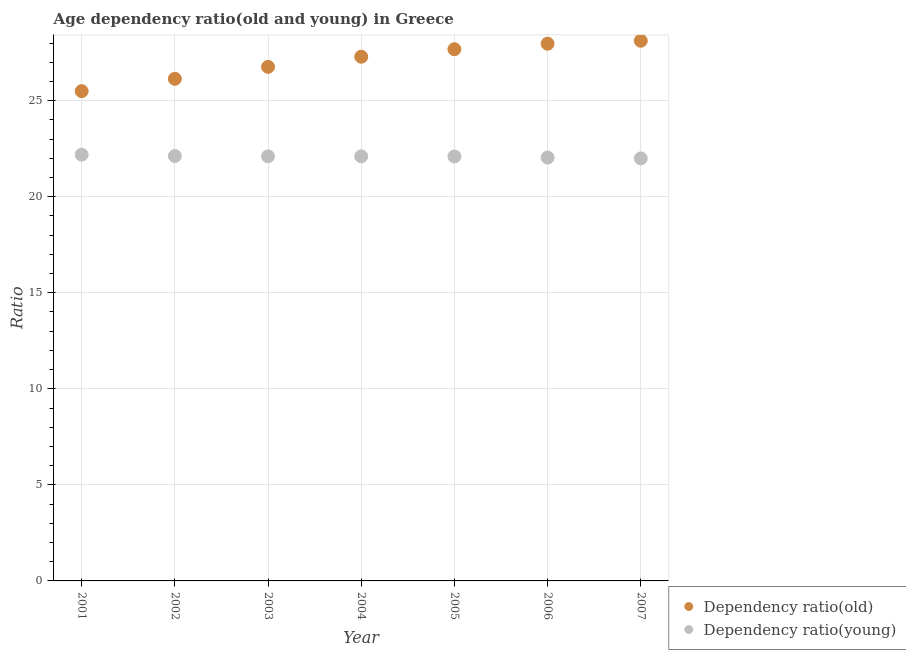How many different coloured dotlines are there?
Make the answer very short. 2. Is the number of dotlines equal to the number of legend labels?
Your answer should be very brief. Yes. What is the age dependency ratio(old) in 2004?
Give a very brief answer. 27.29. Across all years, what is the maximum age dependency ratio(old)?
Your response must be concise. 28.12. Across all years, what is the minimum age dependency ratio(young)?
Give a very brief answer. 21.99. In which year was the age dependency ratio(young) maximum?
Ensure brevity in your answer.  2001. What is the total age dependency ratio(old) in the graph?
Provide a succinct answer. 189.44. What is the difference between the age dependency ratio(old) in 2002 and that in 2006?
Offer a terse response. -1.83. What is the difference between the age dependency ratio(old) in 2005 and the age dependency ratio(young) in 2004?
Keep it short and to the point. 5.58. What is the average age dependency ratio(old) per year?
Provide a succinct answer. 27.06. In the year 2001, what is the difference between the age dependency ratio(old) and age dependency ratio(young)?
Provide a short and direct response. 3.31. What is the ratio of the age dependency ratio(young) in 2003 to that in 2005?
Provide a short and direct response. 1. Is the difference between the age dependency ratio(old) in 2005 and 2007 greater than the difference between the age dependency ratio(young) in 2005 and 2007?
Provide a succinct answer. No. What is the difference between the highest and the second highest age dependency ratio(old)?
Ensure brevity in your answer.  0.15. What is the difference between the highest and the lowest age dependency ratio(young)?
Offer a very short reply. 0.19. In how many years, is the age dependency ratio(old) greater than the average age dependency ratio(old) taken over all years?
Give a very brief answer. 4. Is the sum of the age dependency ratio(young) in 2002 and 2004 greater than the maximum age dependency ratio(old) across all years?
Offer a very short reply. Yes. Does the age dependency ratio(old) monotonically increase over the years?
Give a very brief answer. Yes. Is the age dependency ratio(old) strictly greater than the age dependency ratio(young) over the years?
Your answer should be compact. Yes. Is the age dependency ratio(young) strictly less than the age dependency ratio(old) over the years?
Your answer should be compact. Yes. How many dotlines are there?
Keep it short and to the point. 2. Are the values on the major ticks of Y-axis written in scientific E-notation?
Your response must be concise. No. Does the graph contain any zero values?
Make the answer very short. No. Where does the legend appear in the graph?
Provide a succinct answer. Bottom right. How many legend labels are there?
Provide a succinct answer. 2. What is the title of the graph?
Ensure brevity in your answer.  Age dependency ratio(old and young) in Greece. Does "Mobile cellular" appear as one of the legend labels in the graph?
Provide a succinct answer. No. What is the label or title of the Y-axis?
Your answer should be compact. Ratio. What is the Ratio of Dependency ratio(old) in 2001?
Provide a succinct answer. 25.49. What is the Ratio in Dependency ratio(young) in 2001?
Offer a terse response. 22.19. What is the Ratio in Dependency ratio(old) in 2002?
Offer a terse response. 26.14. What is the Ratio of Dependency ratio(young) in 2002?
Keep it short and to the point. 22.12. What is the Ratio in Dependency ratio(old) in 2003?
Ensure brevity in your answer.  26.76. What is the Ratio of Dependency ratio(young) in 2003?
Give a very brief answer. 22.1. What is the Ratio of Dependency ratio(old) in 2004?
Make the answer very short. 27.29. What is the Ratio in Dependency ratio(young) in 2004?
Your response must be concise. 22.1. What is the Ratio in Dependency ratio(old) in 2005?
Ensure brevity in your answer.  27.68. What is the Ratio in Dependency ratio(young) in 2005?
Your answer should be compact. 22.09. What is the Ratio in Dependency ratio(old) in 2006?
Give a very brief answer. 27.97. What is the Ratio of Dependency ratio(young) in 2006?
Ensure brevity in your answer.  22.04. What is the Ratio of Dependency ratio(old) in 2007?
Ensure brevity in your answer.  28.12. What is the Ratio in Dependency ratio(young) in 2007?
Keep it short and to the point. 21.99. Across all years, what is the maximum Ratio in Dependency ratio(old)?
Your answer should be compact. 28.12. Across all years, what is the maximum Ratio in Dependency ratio(young)?
Offer a very short reply. 22.19. Across all years, what is the minimum Ratio in Dependency ratio(old)?
Offer a terse response. 25.49. Across all years, what is the minimum Ratio in Dependency ratio(young)?
Keep it short and to the point. 21.99. What is the total Ratio in Dependency ratio(old) in the graph?
Provide a succinct answer. 189.44. What is the total Ratio in Dependency ratio(young) in the graph?
Your answer should be very brief. 154.63. What is the difference between the Ratio of Dependency ratio(old) in 2001 and that in 2002?
Offer a very short reply. -0.64. What is the difference between the Ratio of Dependency ratio(young) in 2001 and that in 2002?
Offer a terse response. 0.07. What is the difference between the Ratio of Dependency ratio(old) in 2001 and that in 2003?
Give a very brief answer. -1.27. What is the difference between the Ratio in Dependency ratio(young) in 2001 and that in 2003?
Your response must be concise. 0.09. What is the difference between the Ratio of Dependency ratio(old) in 2001 and that in 2004?
Make the answer very short. -1.79. What is the difference between the Ratio in Dependency ratio(young) in 2001 and that in 2004?
Ensure brevity in your answer.  0.09. What is the difference between the Ratio in Dependency ratio(old) in 2001 and that in 2005?
Your answer should be compact. -2.18. What is the difference between the Ratio in Dependency ratio(young) in 2001 and that in 2005?
Your response must be concise. 0.1. What is the difference between the Ratio of Dependency ratio(old) in 2001 and that in 2006?
Your answer should be very brief. -2.47. What is the difference between the Ratio of Dependency ratio(young) in 2001 and that in 2006?
Provide a succinct answer. 0.15. What is the difference between the Ratio in Dependency ratio(old) in 2001 and that in 2007?
Provide a succinct answer. -2.62. What is the difference between the Ratio in Dependency ratio(young) in 2001 and that in 2007?
Ensure brevity in your answer.  0.19. What is the difference between the Ratio in Dependency ratio(old) in 2002 and that in 2003?
Offer a very short reply. -0.62. What is the difference between the Ratio of Dependency ratio(young) in 2002 and that in 2003?
Give a very brief answer. 0.02. What is the difference between the Ratio of Dependency ratio(old) in 2002 and that in 2004?
Make the answer very short. -1.15. What is the difference between the Ratio in Dependency ratio(young) in 2002 and that in 2004?
Ensure brevity in your answer.  0.02. What is the difference between the Ratio in Dependency ratio(old) in 2002 and that in 2005?
Your answer should be compact. -1.54. What is the difference between the Ratio of Dependency ratio(young) in 2002 and that in 2005?
Provide a succinct answer. 0.02. What is the difference between the Ratio in Dependency ratio(old) in 2002 and that in 2006?
Your answer should be compact. -1.83. What is the difference between the Ratio in Dependency ratio(young) in 2002 and that in 2006?
Provide a succinct answer. 0.08. What is the difference between the Ratio of Dependency ratio(old) in 2002 and that in 2007?
Give a very brief answer. -1.98. What is the difference between the Ratio of Dependency ratio(young) in 2002 and that in 2007?
Make the answer very short. 0.12. What is the difference between the Ratio of Dependency ratio(old) in 2003 and that in 2004?
Give a very brief answer. -0.53. What is the difference between the Ratio of Dependency ratio(young) in 2003 and that in 2004?
Give a very brief answer. 0. What is the difference between the Ratio of Dependency ratio(old) in 2003 and that in 2005?
Keep it short and to the point. -0.92. What is the difference between the Ratio in Dependency ratio(young) in 2003 and that in 2005?
Keep it short and to the point. 0.01. What is the difference between the Ratio in Dependency ratio(old) in 2003 and that in 2006?
Offer a very short reply. -1.2. What is the difference between the Ratio of Dependency ratio(young) in 2003 and that in 2006?
Keep it short and to the point. 0.06. What is the difference between the Ratio in Dependency ratio(old) in 2003 and that in 2007?
Give a very brief answer. -1.36. What is the difference between the Ratio in Dependency ratio(young) in 2003 and that in 2007?
Your answer should be very brief. 0.11. What is the difference between the Ratio in Dependency ratio(old) in 2004 and that in 2005?
Your response must be concise. -0.39. What is the difference between the Ratio in Dependency ratio(young) in 2004 and that in 2005?
Your answer should be very brief. 0.01. What is the difference between the Ratio in Dependency ratio(old) in 2004 and that in 2006?
Your response must be concise. -0.68. What is the difference between the Ratio in Dependency ratio(young) in 2004 and that in 2006?
Keep it short and to the point. 0.06. What is the difference between the Ratio in Dependency ratio(old) in 2004 and that in 2007?
Make the answer very short. -0.83. What is the difference between the Ratio of Dependency ratio(young) in 2004 and that in 2007?
Make the answer very short. 0.11. What is the difference between the Ratio in Dependency ratio(old) in 2005 and that in 2006?
Ensure brevity in your answer.  -0.29. What is the difference between the Ratio of Dependency ratio(young) in 2005 and that in 2006?
Give a very brief answer. 0.05. What is the difference between the Ratio in Dependency ratio(old) in 2005 and that in 2007?
Ensure brevity in your answer.  -0.44. What is the difference between the Ratio in Dependency ratio(young) in 2005 and that in 2007?
Make the answer very short. 0.1. What is the difference between the Ratio in Dependency ratio(old) in 2006 and that in 2007?
Your response must be concise. -0.15. What is the difference between the Ratio in Dependency ratio(young) in 2006 and that in 2007?
Provide a short and direct response. 0.05. What is the difference between the Ratio of Dependency ratio(old) in 2001 and the Ratio of Dependency ratio(young) in 2002?
Make the answer very short. 3.38. What is the difference between the Ratio in Dependency ratio(old) in 2001 and the Ratio in Dependency ratio(young) in 2003?
Offer a very short reply. 3.39. What is the difference between the Ratio of Dependency ratio(old) in 2001 and the Ratio of Dependency ratio(young) in 2004?
Keep it short and to the point. 3.39. What is the difference between the Ratio in Dependency ratio(old) in 2001 and the Ratio in Dependency ratio(young) in 2005?
Give a very brief answer. 3.4. What is the difference between the Ratio of Dependency ratio(old) in 2001 and the Ratio of Dependency ratio(young) in 2006?
Provide a short and direct response. 3.46. What is the difference between the Ratio in Dependency ratio(old) in 2001 and the Ratio in Dependency ratio(young) in 2007?
Keep it short and to the point. 3.5. What is the difference between the Ratio in Dependency ratio(old) in 2002 and the Ratio in Dependency ratio(young) in 2003?
Ensure brevity in your answer.  4.04. What is the difference between the Ratio of Dependency ratio(old) in 2002 and the Ratio of Dependency ratio(young) in 2004?
Your answer should be compact. 4.04. What is the difference between the Ratio in Dependency ratio(old) in 2002 and the Ratio in Dependency ratio(young) in 2005?
Provide a short and direct response. 4.05. What is the difference between the Ratio in Dependency ratio(old) in 2002 and the Ratio in Dependency ratio(young) in 2006?
Offer a terse response. 4.1. What is the difference between the Ratio in Dependency ratio(old) in 2002 and the Ratio in Dependency ratio(young) in 2007?
Ensure brevity in your answer.  4.14. What is the difference between the Ratio in Dependency ratio(old) in 2003 and the Ratio in Dependency ratio(young) in 2004?
Offer a very short reply. 4.66. What is the difference between the Ratio in Dependency ratio(old) in 2003 and the Ratio in Dependency ratio(young) in 2005?
Ensure brevity in your answer.  4.67. What is the difference between the Ratio in Dependency ratio(old) in 2003 and the Ratio in Dependency ratio(young) in 2006?
Provide a succinct answer. 4.72. What is the difference between the Ratio in Dependency ratio(old) in 2003 and the Ratio in Dependency ratio(young) in 2007?
Provide a short and direct response. 4.77. What is the difference between the Ratio of Dependency ratio(old) in 2004 and the Ratio of Dependency ratio(young) in 2005?
Give a very brief answer. 5.19. What is the difference between the Ratio in Dependency ratio(old) in 2004 and the Ratio in Dependency ratio(young) in 2006?
Offer a very short reply. 5.25. What is the difference between the Ratio of Dependency ratio(old) in 2004 and the Ratio of Dependency ratio(young) in 2007?
Your response must be concise. 5.29. What is the difference between the Ratio in Dependency ratio(old) in 2005 and the Ratio in Dependency ratio(young) in 2006?
Your answer should be very brief. 5.64. What is the difference between the Ratio of Dependency ratio(old) in 2005 and the Ratio of Dependency ratio(young) in 2007?
Your answer should be very brief. 5.68. What is the difference between the Ratio in Dependency ratio(old) in 2006 and the Ratio in Dependency ratio(young) in 2007?
Your answer should be compact. 5.97. What is the average Ratio in Dependency ratio(old) per year?
Keep it short and to the point. 27.06. What is the average Ratio in Dependency ratio(young) per year?
Offer a very short reply. 22.09. In the year 2001, what is the difference between the Ratio in Dependency ratio(old) and Ratio in Dependency ratio(young)?
Your response must be concise. 3.31. In the year 2002, what is the difference between the Ratio in Dependency ratio(old) and Ratio in Dependency ratio(young)?
Offer a very short reply. 4.02. In the year 2003, what is the difference between the Ratio of Dependency ratio(old) and Ratio of Dependency ratio(young)?
Make the answer very short. 4.66. In the year 2004, what is the difference between the Ratio of Dependency ratio(old) and Ratio of Dependency ratio(young)?
Offer a very short reply. 5.19. In the year 2005, what is the difference between the Ratio of Dependency ratio(old) and Ratio of Dependency ratio(young)?
Provide a succinct answer. 5.59. In the year 2006, what is the difference between the Ratio of Dependency ratio(old) and Ratio of Dependency ratio(young)?
Offer a terse response. 5.93. In the year 2007, what is the difference between the Ratio of Dependency ratio(old) and Ratio of Dependency ratio(young)?
Ensure brevity in your answer.  6.12. What is the ratio of the Ratio of Dependency ratio(old) in 2001 to that in 2002?
Provide a succinct answer. 0.98. What is the ratio of the Ratio of Dependency ratio(young) in 2001 to that in 2002?
Your response must be concise. 1. What is the ratio of the Ratio in Dependency ratio(old) in 2001 to that in 2003?
Ensure brevity in your answer.  0.95. What is the ratio of the Ratio in Dependency ratio(young) in 2001 to that in 2003?
Keep it short and to the point. 1. What is the ratio of the Ratio of Dependency ratio(old) in 2001 to that in 2004?
Make the answer very short. 0.93. What is the ratio of the Ratio of Dependency ratio(young) in 2001 to that in 2004?
Provide a short and direct response. 1. What is the ratio of the Ratio in Dependency ratio(old) in 2001 to that in 2005?
Provide a short and direct response. 0.92. What is the ratio of the Ratio in Dependency ratio(old) in 2001 to that in 2006?
Ensure brevity in your answer.  0.91. What is the ratio of the Ratio of Dependency ratio(young) in 2001 to that in 2006?
Your response must be concise. 1.01. What is the ratio of the Ratio of Dependency ratio(old) in 2001 to that in 2007?
Offer a terse response. 0.91. What is the ratio of the Ratio in Dependency ratio(young) in 2001 to that in 2007?
Provide a succinct answer. 1.01. What is the ratio of the Ratio of Dependency ratio(old) in 2002 to that in 2003?
Offer a terse response. 0.98. What is the ratio of the Ratio of Dependency ratio(old) in 2002 to that in 2004?
Ensure brevity in your answer.  0.96. What is the ratio of the Ratio in Dependency ratio(young) in 2002 to that in 2004?
Provide a short and direct response. 1. What is the ratio of the Ratio of Dependency ratio(old) in 2002 to that in 2006?
Give a very brief answer. 0.93. What is the ratio of the Ratio in Dependency ratio(young) in 2002 to that in 2006?
Give a very brief answer. 1. What is the ratio of the Ratio in Dependency ratio(old) in 2002 to that in 2007?
Keep it short and to the point. 0.93. What is the ratio of the Ratio of Dependency ratio(young) in 2002 to that in 2007?
Offer a terse response. 1.01. What is the ratio of the Ratio of Dependency ratio(old) in 2003 to that in 2004?
Keep it short and to the point. 0.98. What is the ratio of the Ratio of Dependency ratio(old) in 2003 to that in 2005?
Offer a terse response. 0.97. What is the ratio of the Ratio of Dependency ratio(old) in 2003 to that in 2006?
Keep it short and to the point. 0.96. What is the ratio of the Ratio of Dependency ratio(young) in 2003 to that in 2006?
Provide a succinct answer. 1. What is the ratio of the Ratio in Dependency ratio(old) in 2003 to that in 2007?
Keep it short and to the point. 0.95. What is the ratio of the Ratio of Dependency ratio(old) in 2004 to that in 2005?
Ensure brevity in your answer.  0.99. What is the ratio of the Ratio in Dependency ratio(young) in 2004 to that in 2005?
Ensure brevity in your answer.  1. What is the ratio of the Ratio in Dependency ratio(old) in 2004 to that in 2006?
Your answer should be compact. 0.98. What is the ratio of the Ratio in Dependency ratio(young) in 2004 to that in 2006?
Offer a very short reply. 1. What is the ratio of the Ratio in Dependency ratio(old) in 2004 to that in 2007?
Give a very brief answer. 0.97. What is the ratio of the Ratio in Dependency ratio(young) in 2004 to that in 2007?
Offer a terse response. 1. What is the ratio of the Ratio of Dependency ratio(young) in 2005 to that in 2006?
Keep it short and to the point. 1. What is the ratio of the Ratio in Dependency ratio(old) in 2005 to that in 2007?
Ensure brevity in your answer.  0.98. What is the difference between the highest and the second highest Ratio of Dependency ratio(old)?
Keep it short and to the point. 0.15. What is the difference between the highest and the second highest Ratio in Dependency ratio(young)?
Give a very brief answer. 0.07. What is the difference between the highest and the lowest Ratio in Dependency ratio(old)?
Ensure brevity in your answer.  2.62. What is the difference between the highest and the lowest Ratio in Dependency ratio(young)?
Your answer should be very brief. 0.19. 